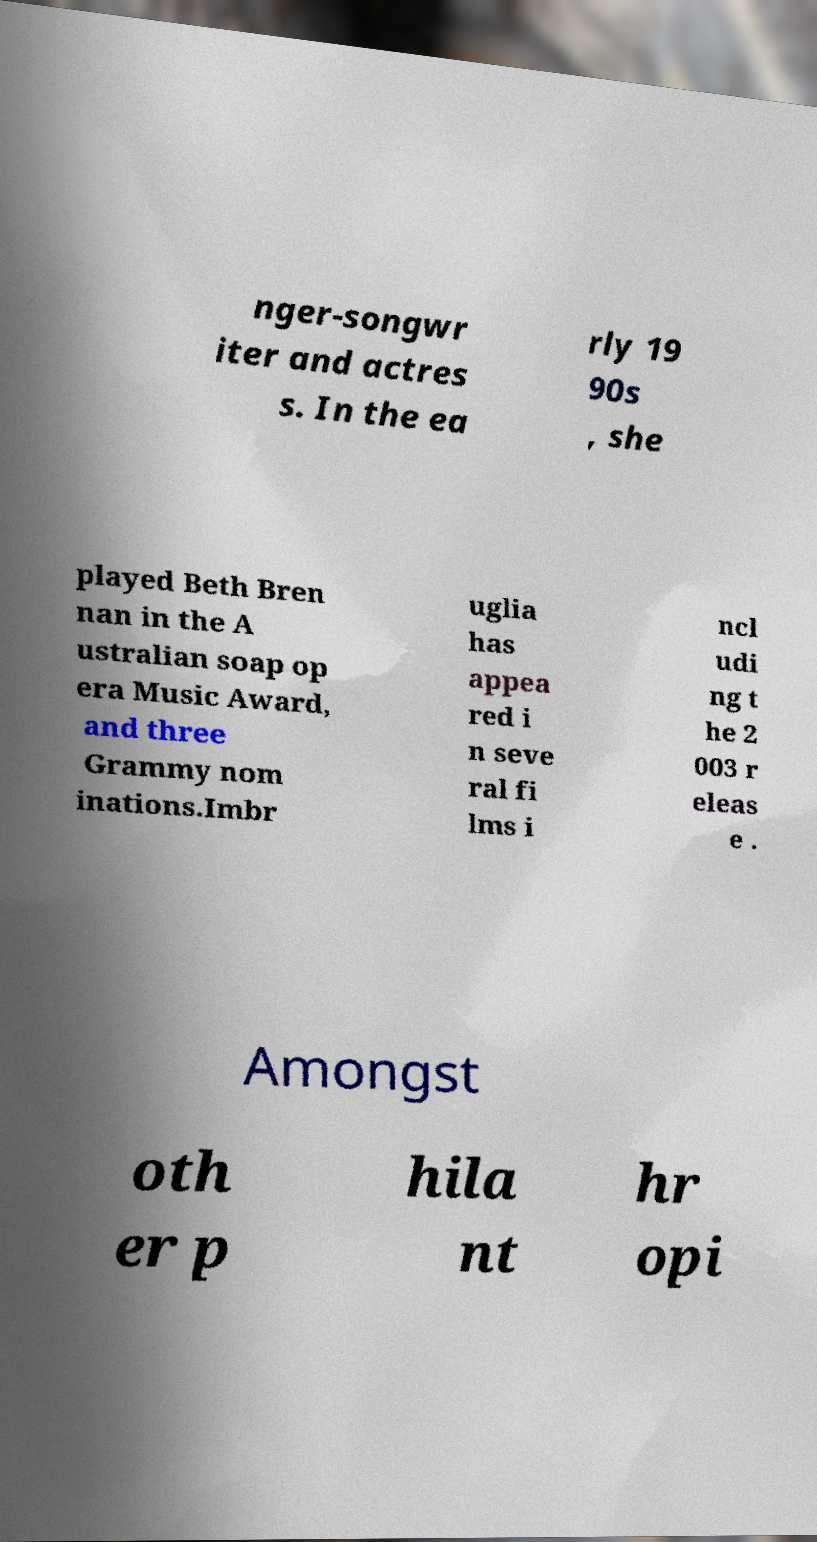Could you assist in decoding the text presented in this image and type it out clearly? nger-songwr iter and actres s. In the ea rly 19 90s , she played Beth Bren nan in the A ustralian soap op era Music Award, and three Grammy nom inations.Imbr uglia has appea red i n seve ral fi lms i ncl udi ng t he 2 003 r eleas e . Amongst oth er p hila nt hr opi 